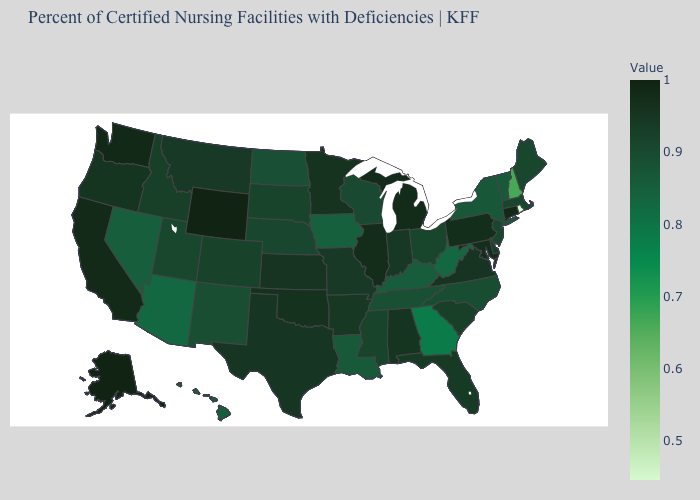Is the legend a continuous bar?
Be succinct. Yes. Does Tennessee have a lower value than Georgia?
Keep it brief. No. Does Florida have the highest value in the South?
Give a very brief answer. No. 